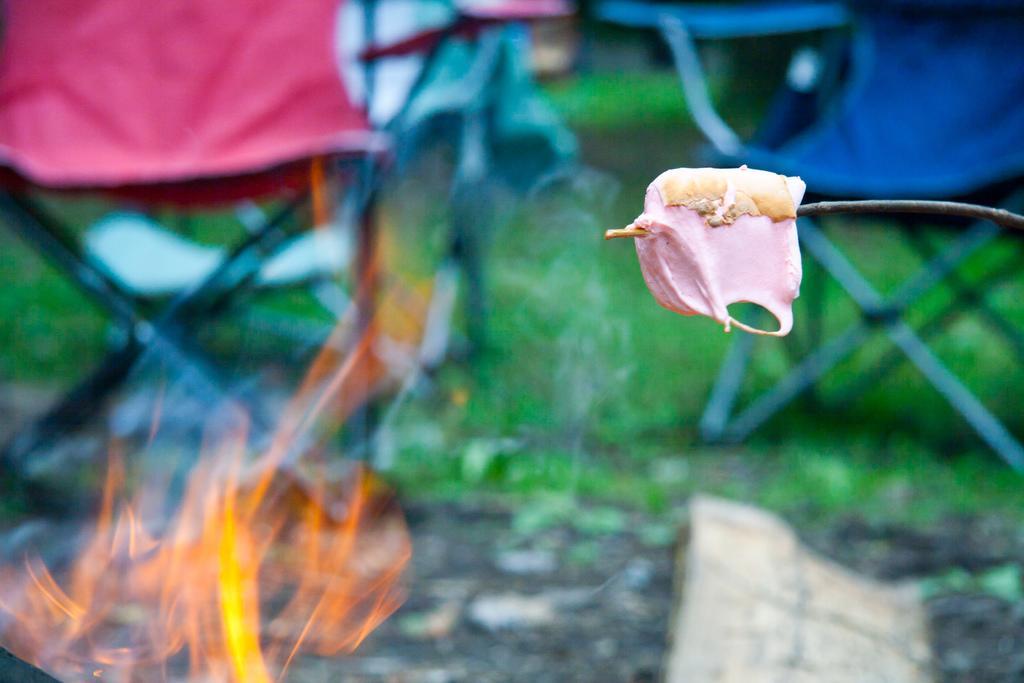Can you describe this image briefly? It seems like a food object on the stem in the foreground of the image. In the background, we can see fire, grassy land and chairs. 